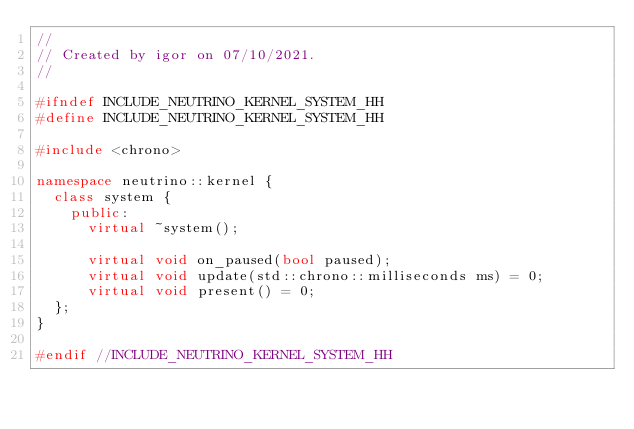<code> <loc_0><loc_0><loc_500><loc_500><_C++_>//
// Created by igor on 07/10/2021.
//

#ifndef INCLUDE_NEUTRINO_KERNEL_SYSTEM_HH
#define INCLUDE_NEUTRINO_KERNEL_SYSTEM_HH

#include <chrono>

namespace neutrino::kernel {
  class system {
    public:
      virtual ~system();

      virtual void on_paused(bool paused);
      virtual void update(std::chrono::milliseconds ms) = 0;
      virtual void present() = 0;
  };
}

#endif //INCLUDE_NEUTRINO_KERNEL_SYSTEM_HH
</code> 